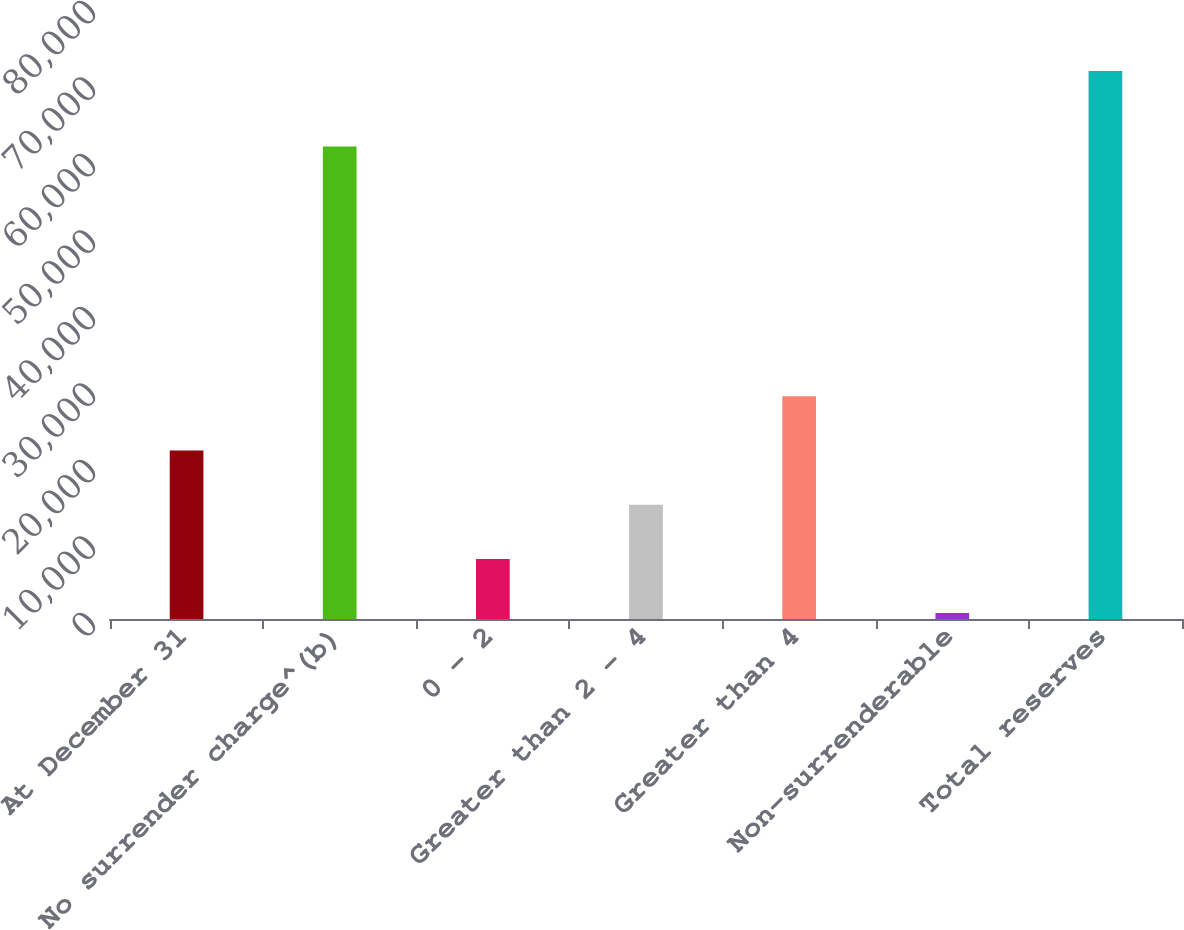Convert chart. <chart><loc_0><loc_0><loc_500><loc_500><bar_chart><fcel>At December 31<fcel>No surrender charge^(b)<fcel>0 - 2<fcel>Greater than 2 - 4<fcel>Greater than 4<fcel>Non-surrenderable<fcel>Total reserves<nl><fcel>22024.7<fcel>61751<fcel>7854.9<fcel>14939.8<fcel>29109.6<fcel>770<fcel>71619<nl></chart> 